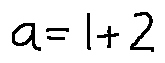Convert formula to latex. <formula><loc_0><loc_0><loc_500><loc_500>a = 1 + 2</formula> 